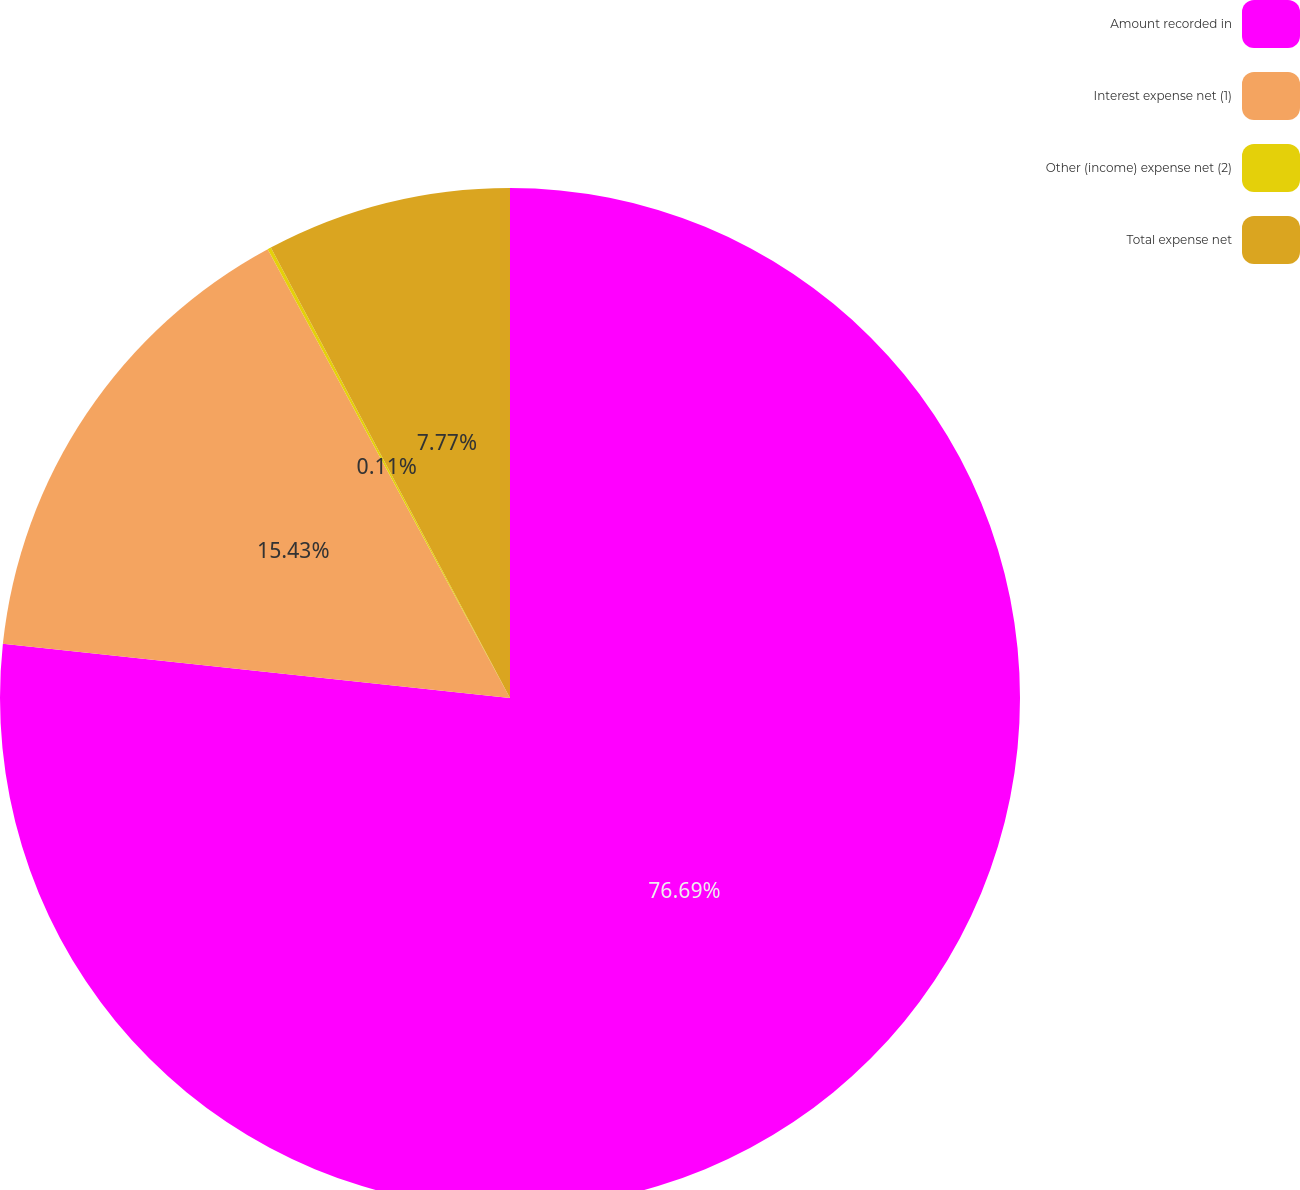Convert chart to OTSL. <chart><loc_0><loc_0><loc_500><loc_500><pie_chart><fcel>Amount recorded in<fcel>Interest expense net (1)<fcel>Other (income) expense net (2)<fcel>Total expense net<nl><fcel>76.7%<fcel>15.43%<fcel>0.11%<fcel>7.77%<nl></chart> 